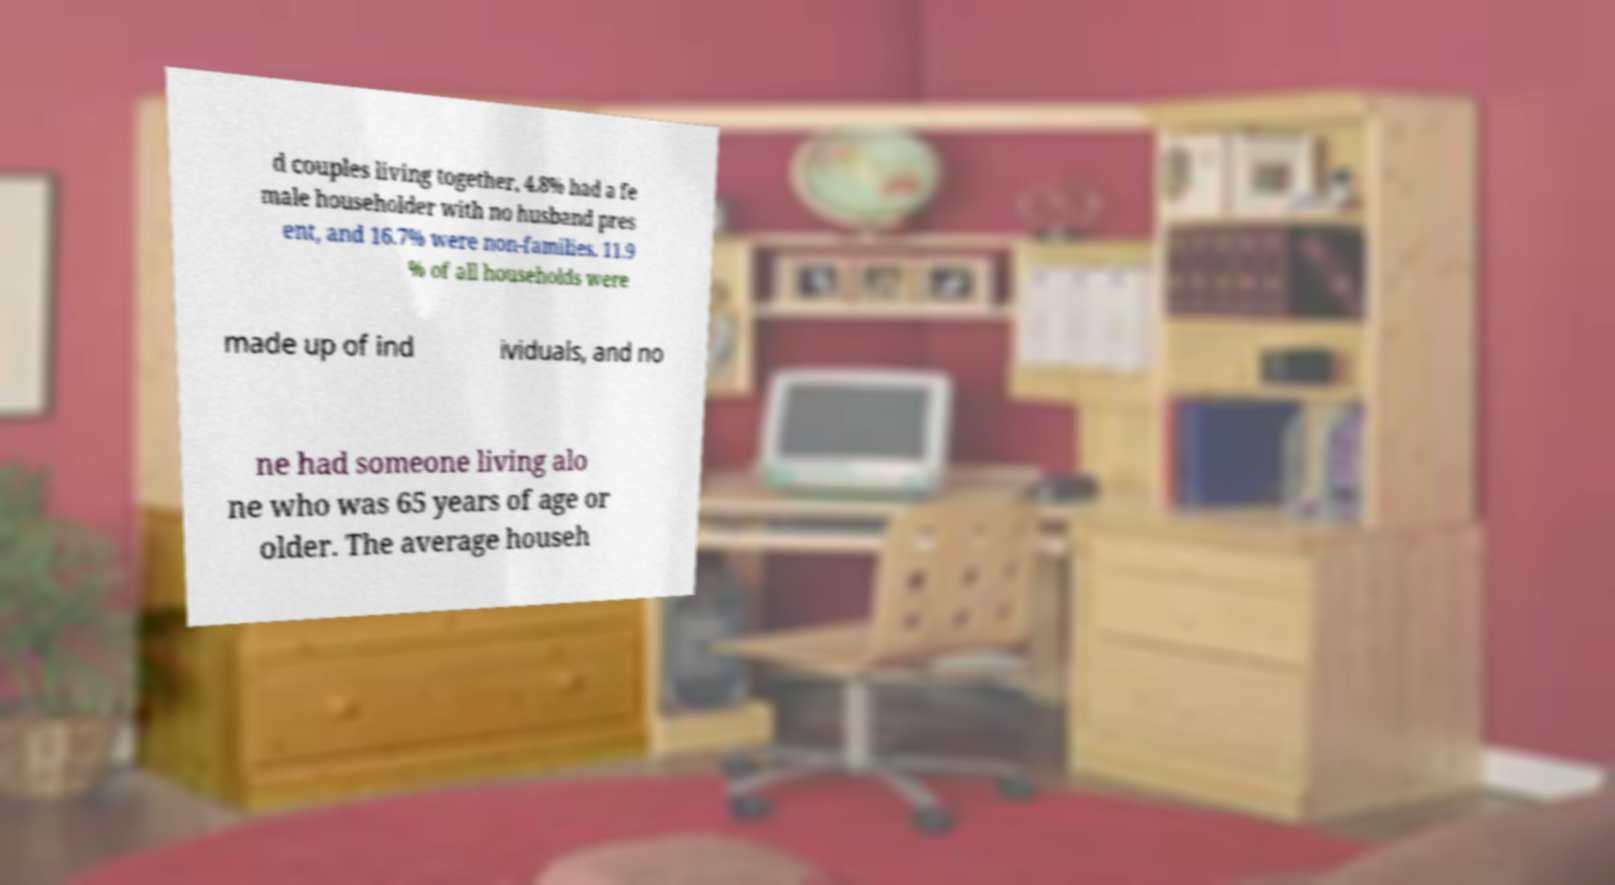There's text embedded in this image that I need extracted. Can you transcribe it verbatim? d couples living together, 4.8% had a fe male householder with no husband pres ent, and 16.7% were non-families. 11.9 % of all households were made up of ind ividuals, and no ne had someone living alo ne who was 65 years of age or older. The average househ 